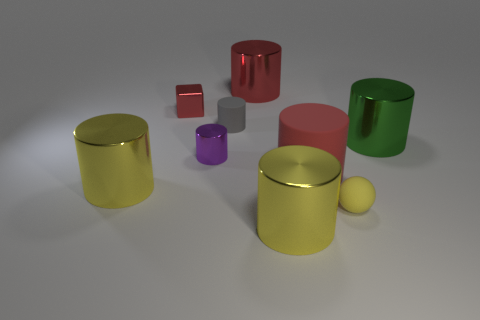What color is the cube that is made of the same material as the green thing?
Offer a very short reply. Red. Are there fewer matte balls than tiny matte objects?
Keep it short and to the point. Yes. There is a cylinder on the left side of the tiny cylinder that is in front of the rubber cylinder that is to the left of the red matte object; what is its material?
Ensure brevity in your answer.  Metal. What is the small yellow object made of?
Your answer should be compact. Rubber. Does the metallic thing that is in front of the small yellow matte thing have the same color as the small object that is in front of the small purple cylinder?
Provide a short and direct response. Yes. Is the number of tiny spheres greater than the number of tiny yellow cubes?
Make the answer very short. Yes. What number of rubber balls are the same color as the small cube?
Make the answer very short. 0. What is the color of the other tiny thing that is the same shape as the purple object?
Keep it short and to the point. Gray. What is the material of the object that is behind the tiny sphere and to the right of the large red matte cylinder?
Keep it short and to the point. Metal. Is the material of the big thing that is on the left side of the tiny purple thing the same as the large red cylinder behind the small purple cylinder?
Offer a very short reply. Yes. 